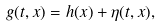<formula> <loc_0><loc_0><loc_500><loc_500>g ( t , x ) = h ( x ) + \eta ( t , x ) ,</formula> 